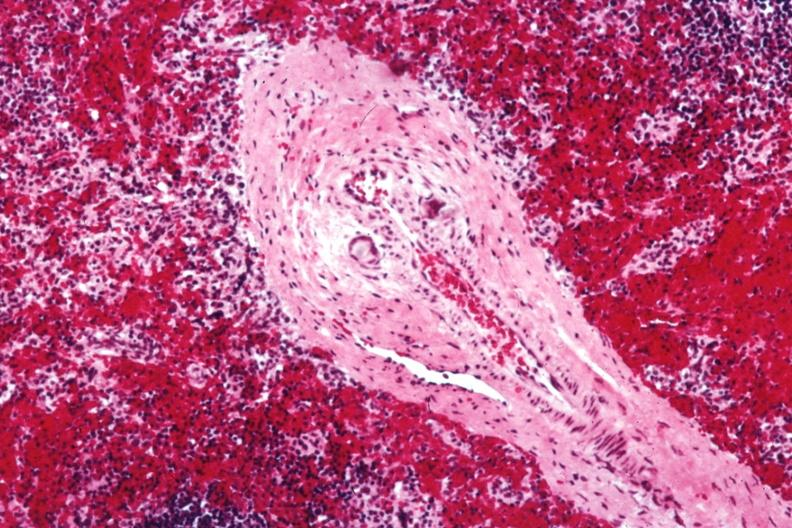s spleen present?
Answer the question using a single word or phrase. Yes 